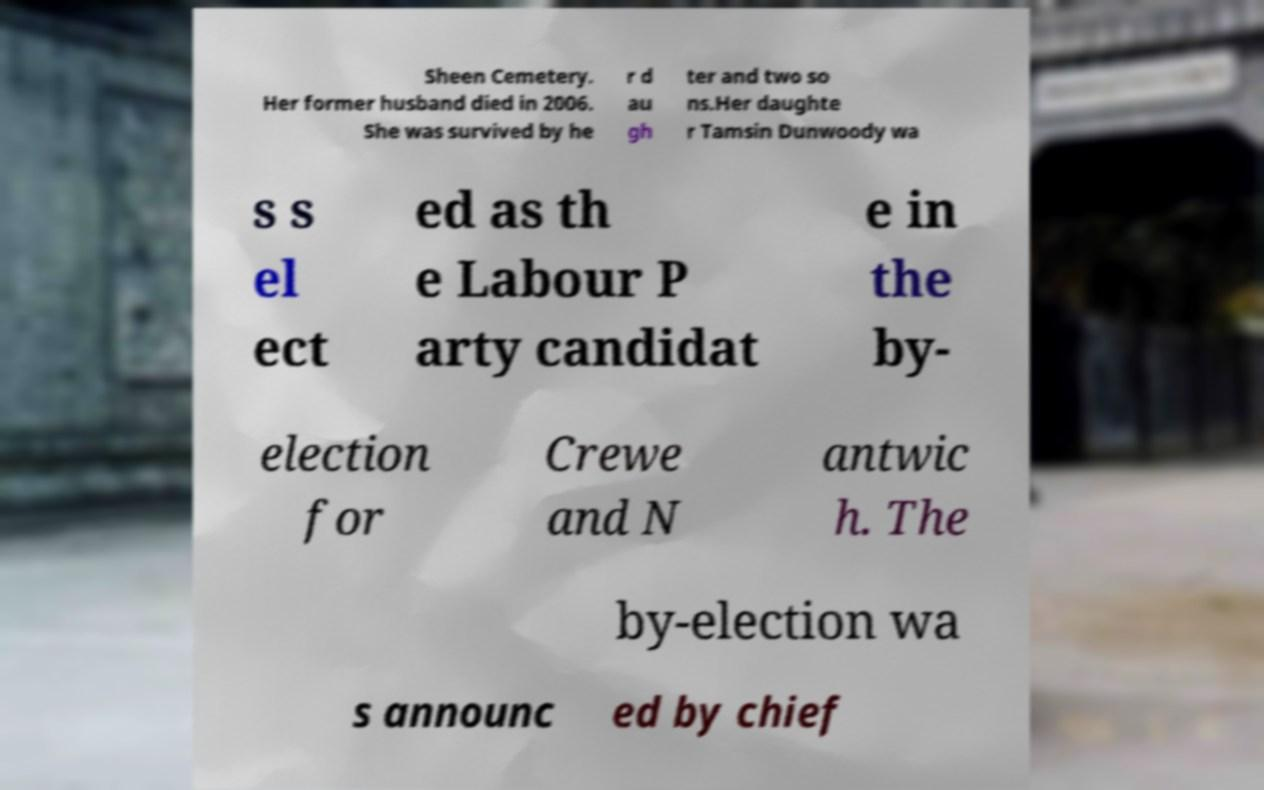I need the written content from this picture converted into text. Can you do that? Sheen Cemetery. Her former husband died in 2006. She was survived by he r d au gh ter and two so ns.Her daughte r Tamsin Dunwoody wa s s el ect ed as th e Labour P arty candidat e in the by- election for Crewe and N antwic h. The by-election wa s announc ed by chief 